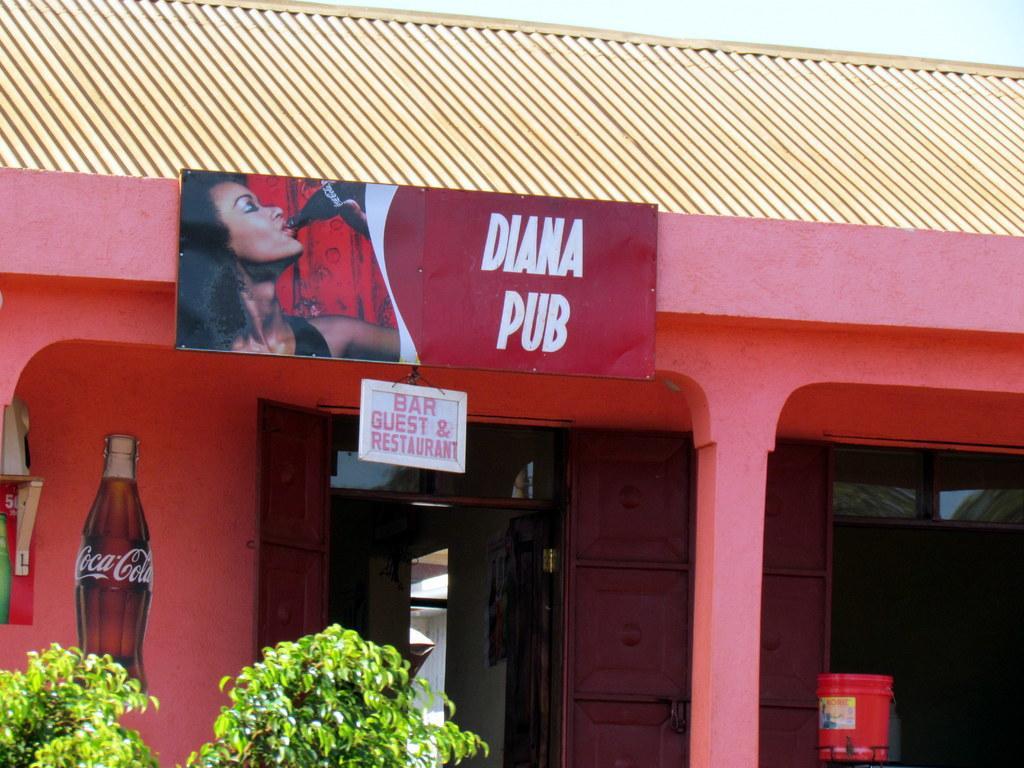In one or two sentences, can you explain what this image depicts? In this image in the center there is a building and there is a board with some text written on the board. In the front there are plants and the sky is cloudy. In front of the the wall there is a red colour object and on the wall there is a drawing of a bottle. 